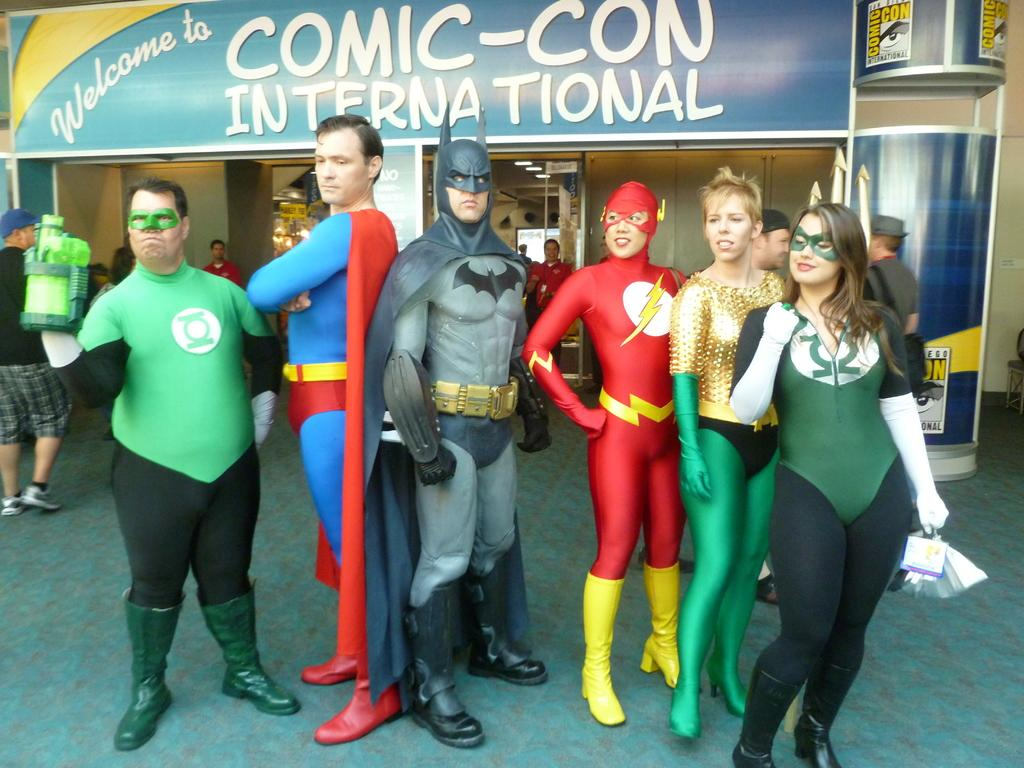What are the people in the image doing? The people in the image are standing, and there is also a man walking. What are the people wearing? The people are wearing fancy dress. What can be seen on the hoarding board in the image? There is a hoarding board with text in the image. Where are the people standing in relation to the hoarding board? There are people standing near the hoarding board. Can you tell me the weight of the tiger in the image? There is no tiger present in the image, so it is not possible to determine its weight. 